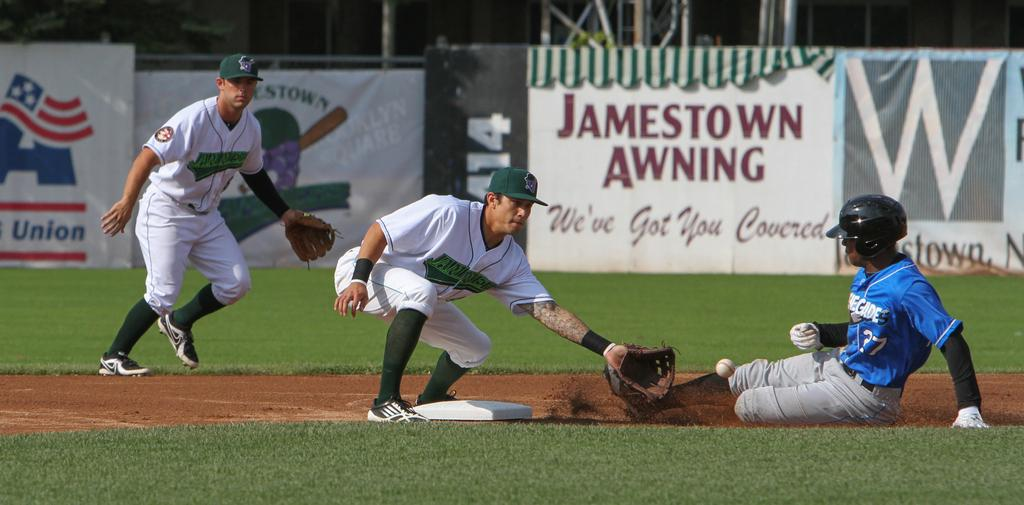<image>
Provide a brief description of the given image. Jamestown Awning is advertised at this teams grounds. 